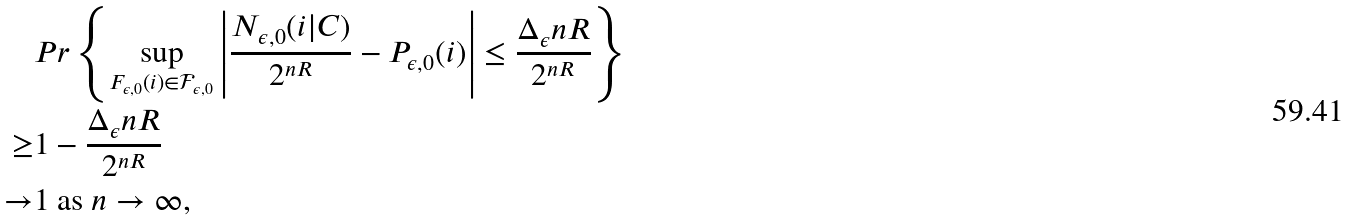Convert formula to latex. <formula><loc_0><loc_0><loc_500><loc_500>& P r \left \{ \sup _ { F _ { \epsilon , 0 } ( i ) \in \mathcal { F } _ { \epsilon , 0 } } \left | \frac { N _ { \epsilon , 0 } ( i | { C } ) } { 2 ^ { n R } } - P _ { \epsilon , 0 } ( i ) \right | \leq \frac { \Delta _ { \epsilon } n R } { 2 ^ { n R } } \right \} \\ \geq & 1 - \frac { \Delta _ { \epsilon } n R } { 2 ^ { n R } } \\ \to & 1 \ \text {as} \ n \to \infty ,</formula> 